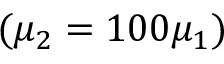Convert formula to latex. <formula><loc_0><loc_0><loc_500><loc_500>( \mu _ { 2 } = 1 0 0 \mu _ { 1 } )</formula> 